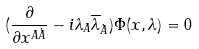Convert formula to latex. <formula><loc_0><loc_0><loc_500><loc_500>( \frac { \partial } { \partial x ^ { A \dot { A } } } - i \lambda _ { A } \overline { \lambda } _ { \dot { A } } ) \Phi ( x , \lambda ) = 0</formula> 